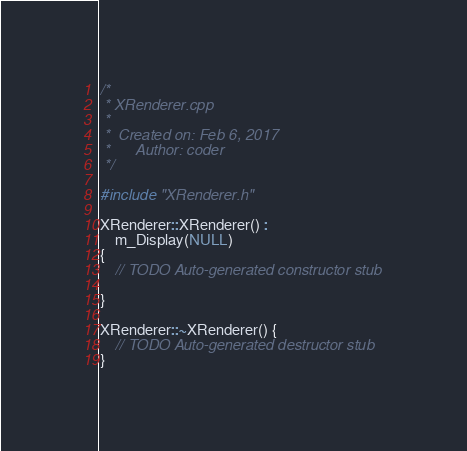Convert code to text. <code><loc_0><loc_0><loc_500><loc_500><_C++_>/*
 * XRenderer.cpp
 *
 *  Created on: Feb 6, 2017
 *      Author: coder
 */

#include "XRenderer.h"

XRenderer::XRenderer() :
	m_Display(NULL)
{
	// TODO Auto-generated constructor stub

}

XRenderer::~XRenderer() {
	// TODO Auto-generated destructor stub
}

</code> 